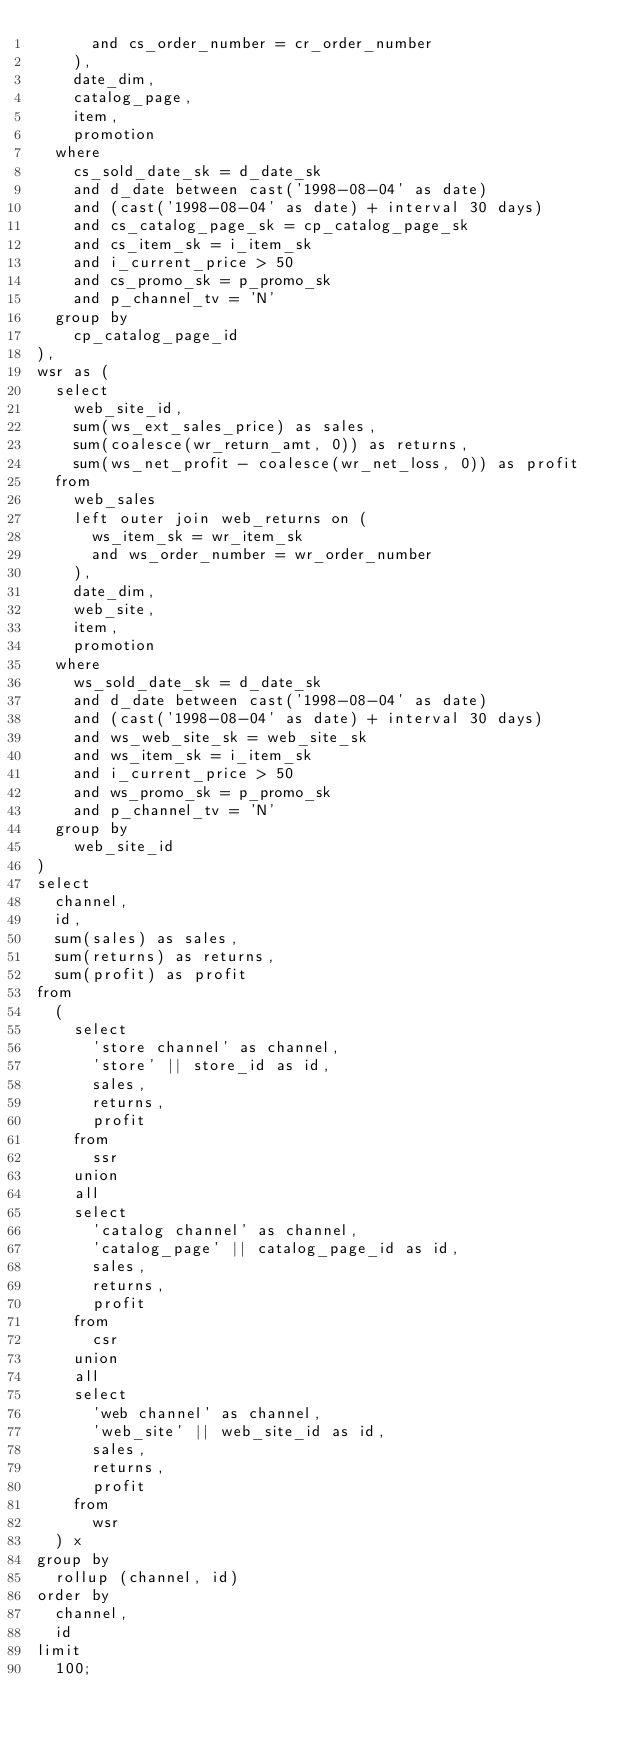Convert code to text. <code><loc_0><loc_0><loc_500><loc_500><_SQL_>      and cs_order_number = cr_order_number
    ),
    date_dim,
    catalog_page,
    item,
    promotion
  where
    cs_sold_date_sk = d_date_sk
    and d_date between cast('1998-08-04' as date)
    and (cast('1998-08-04' as date) + interval 30 days)
    and cs_catalog_page_sk = cp_catalog_page_sk
    and cs_item_sk = i_item_sk
    and i_current_price > 50
    and cs_promo_sk = p_promo_sk
    and p_channel_tv = 'N'
  group by
    cp_catalog_page_id
),
wsr as (
  select
    web_site_id,
    sum(ws_ext_sales_price) as sales,
    sum(coalesce(wr_return_amt, 0)) as returns,
    sum(ws_net_profit - coalesce(wr_net_loss, 0)) as profit
  from
    web_sales
    left outer join web_returns on (
      ws_item_sk = wr_item_sk
      and ws_order_number = wr_order_number
    ),
    date_dim,
    web_site,
    item,
    promotion
  where
    ws_sold_date_sk = d_date_sk
    and d_date between cast('1998-08-04' as date)
    and (cast('1998-08-04' as date) + interval 30 days)
    and ws_web_site_sk = web_site_sk
    and ws_item_sk = i_item_sk
    and i_current_price > 50
    and ws_promo_sk = p_promo_sk
    and p_channel_tv = 'N'
  group by
    web_site_id
)
select
  channel,
  id,
  sum(sales) as sales,
  sum(returns) as returns,
  sum(profit) as profit
from
  (
    select
      'store channel' as channel,
      'store' || store_id as id,
      sales,
      returns,
      profit
    from
      ssr
    union
    all
    select
      'catalog channel' as channel,
      'catalog_page' || catalog_page_id as id,
      sales,
      returns,
      profit
    from
      csr
    union
    all
    select
      'web channel' as channel,
      'web_site' || web_site_id as id,
      sales,
      returns,
      profit
    from
      wsr
  ) x
group by
  rollup (channel, id)
order by
  channel,
  id
limit
  100;
</code> 